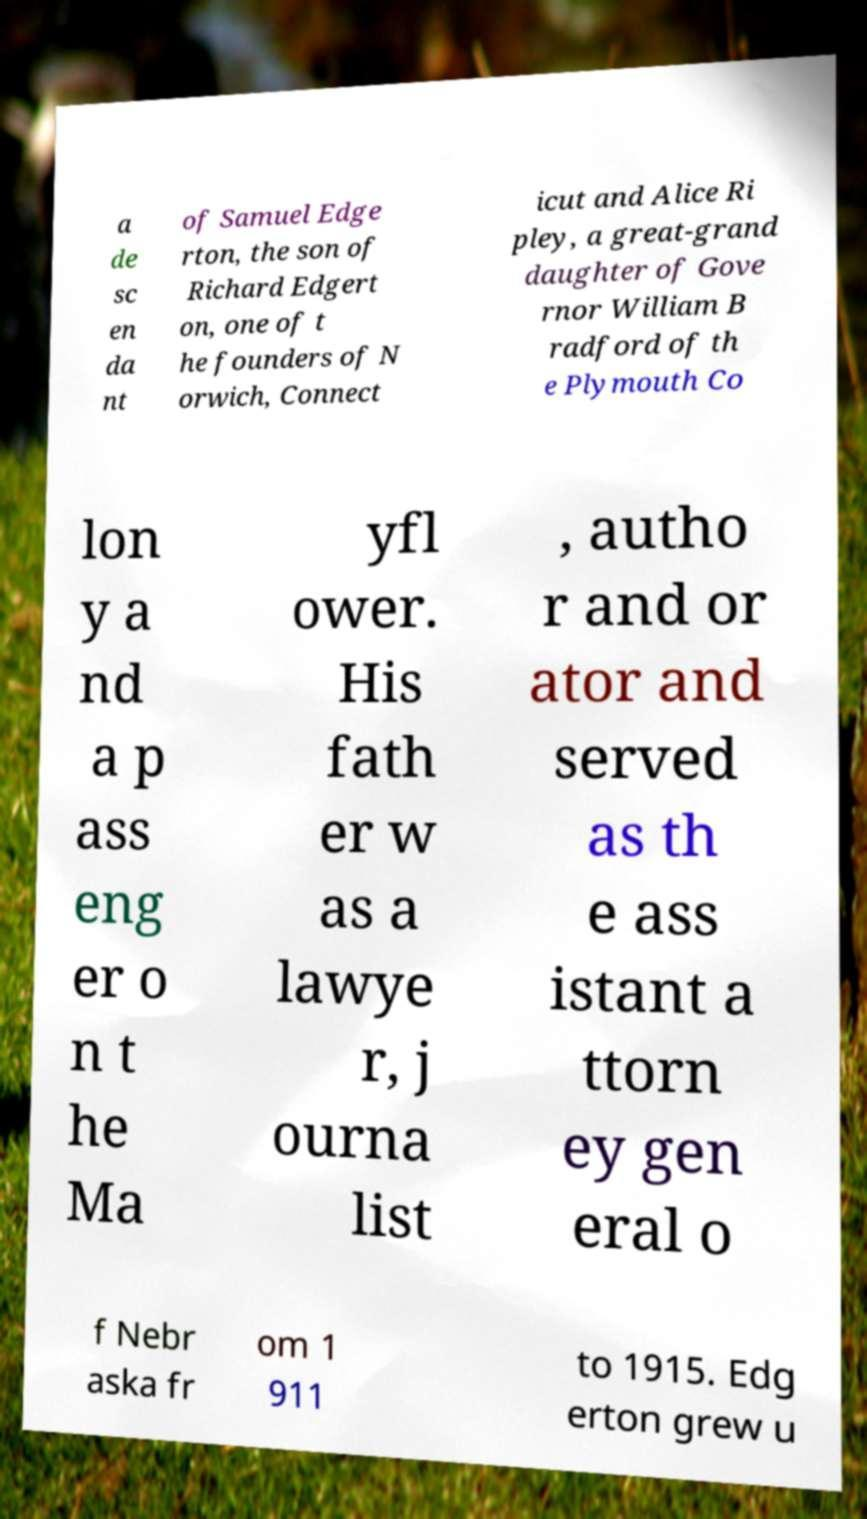For documentation purposes, I need the text within this image transcribed. Could you provide that? a de sc en da nt of Samuel Edge rton, the son of Richard Edgert on, one of t he founders of N orwich, Connect icut and Alice Ri pley, a great-grand daughter of Gove rnor William B radford of th e Plymouth Co lon y a nd a p ass eng er o n t he Ma yfl ower. His fath er w as a lawye r, j ourna list , autho r and or ator and served as th e ass istant a ttorn ey gen eral o f Nebr aska fr om 1 911 to 1915. Edg erton grew u 